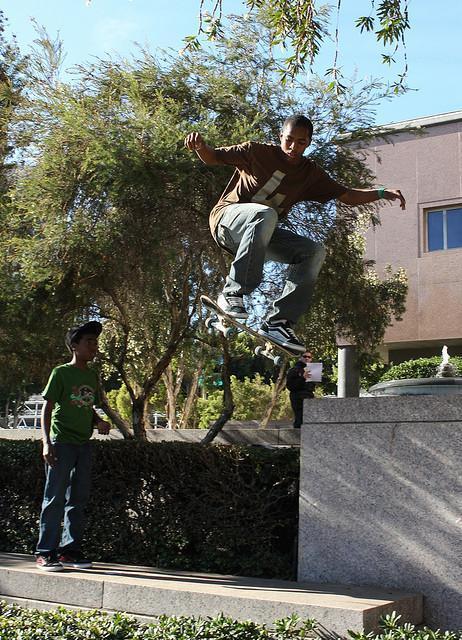How many boys are shown?
Give a very brief answer. 2. How many people are in the picture?
Give a very brief answer. 2. How many people are between the two orange buses in the image?
Give a very brief answer. 0. 